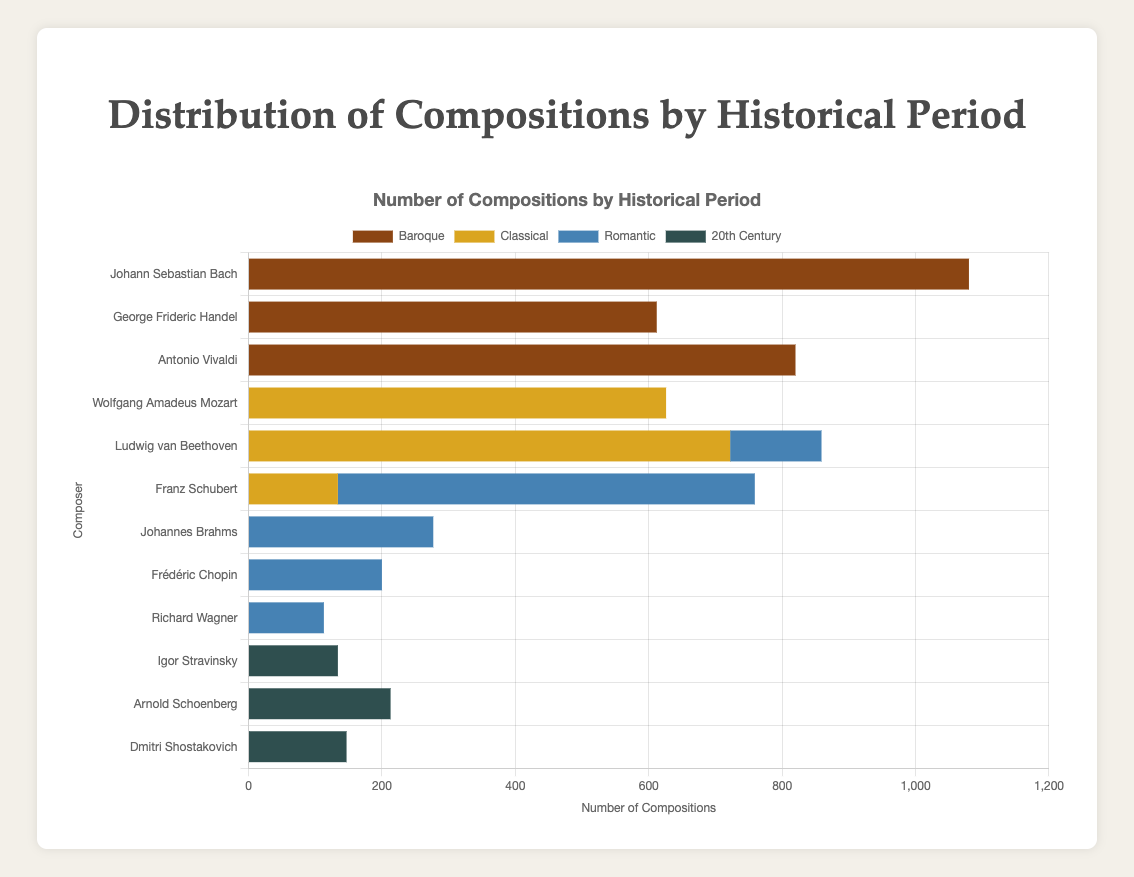Which composer has the largest number of Baroque compositions? Johann Sebastian Bach has the largest segment in the Baroque period with 1080 compositions.
Answer: Johann Sebastian Bach Who composed more Classical period works, Wolfgang Amadeus Mozart or Ludwig van Beethoven? Compare the segments of the two composers in the Classical period; Mozart has 626 compositions while Beethoven has 722.
Answer: Ludwig van Beethoven Among the listed composers, who has compositions spanning both the Classical and Romantic periods? Observe the segments for composers with data in both periods; Ludwig van Beethoven and Franz Schubert are such composers.
Answer: Ludwig van Beethoven, Franz Schubert What is the total number of compositions by Antonio Vivaldi and George Frideric Handel combined in the Baroque period? Sum their Baroque compositions: Vivaldi (820) + Handel (612) = 1432.
Answer: 1432 Which period has the fewest compositions, and who is the major contributor to that period? Count the total compositions in each period and identify the smallest sum, which is the 20th Century with contributions mainly from Arnold Schoenberg, Dmitri Shostakovich, and Igor Stravinsky.
Answer: 20th Century, Arnold Schoenberg By how many compositions does Johann Sebastian Bach exceed Antonio Vivaldi in the Baroque period? Subtract Vivaldi's Baroque compositions from Bach's: 1080 - 820 = 260.
Answer: 260 Which period shows compositions from the highest number of different composers? Count the unique composers contributing to each period: Baroque (3), Classical (3), Romantic (5), and 20th Century (3). The Romantic period has the most composers.
Answer: Romantic What is the sum of the compositions of Arnold Schoenberg and Dmitri Shostakovich in the 20th Century? Sum their 20th Century compositions: Schoenberg (213) + Shostakovich (147) = 360.
Answer: 360 Compare the number of Romantic compositions by Franz Schubert and Johannes Brahms. Who composed more? Franz Schubert has 625 compositions, while Johannes Brahms has 277 in the Romantic period.
Answer: Franz Schubert Which color represents the Romantic period compositions in the chart? Identify the color corresponding to the Romantic compositions based on the chart's legend.
Answer: Steel Blue 